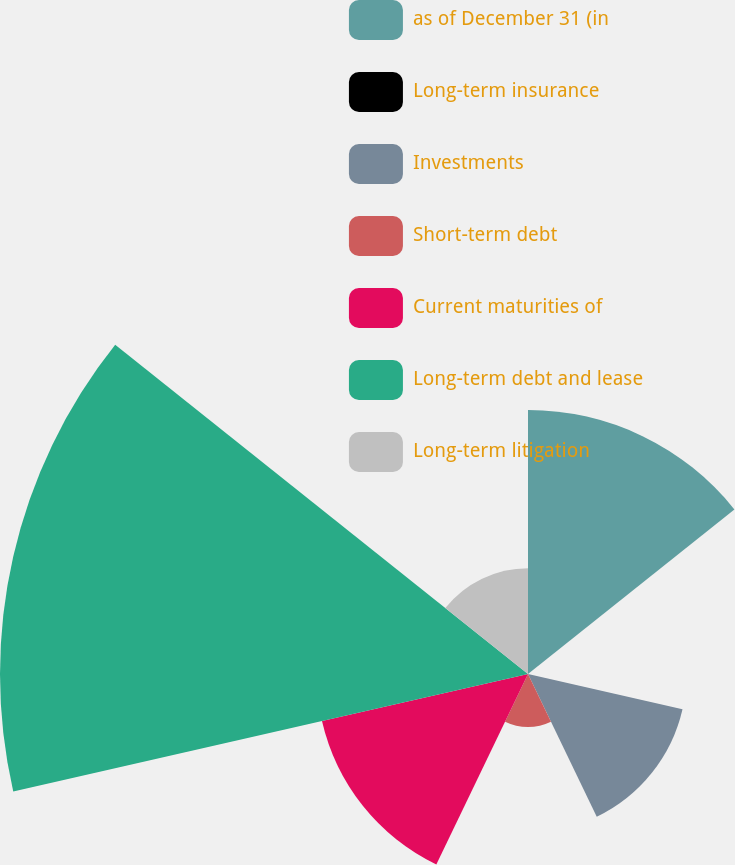Convert chart. <chart><loc_0><loc_0><loc_500><loc_500><pie_chart><fcel>as of December 31 (in<fcel>Long-term insurance<fcel>Investments<fcel>Short-term debt<fcel>Current maturities of<fcel>Long-term debt and lease<fcel>Long-term litigation<nl><fcel>19.99%<fcel>0.01%<fcel>12.0%<fcel>4.01%<fcel>16.0%<fcel>39.98%<fcel>8.01%<nl></chart> 